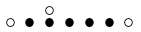Convert formula to latex. <formula><loc_0><loc_0><loc_500><loc_500>\begin{smallmatrix} & & \circ \\ \circ & \bullet & \bullet & \bullet & \bullet & \bullet & \circ & \\ \end{smallmatrix}</formula> 